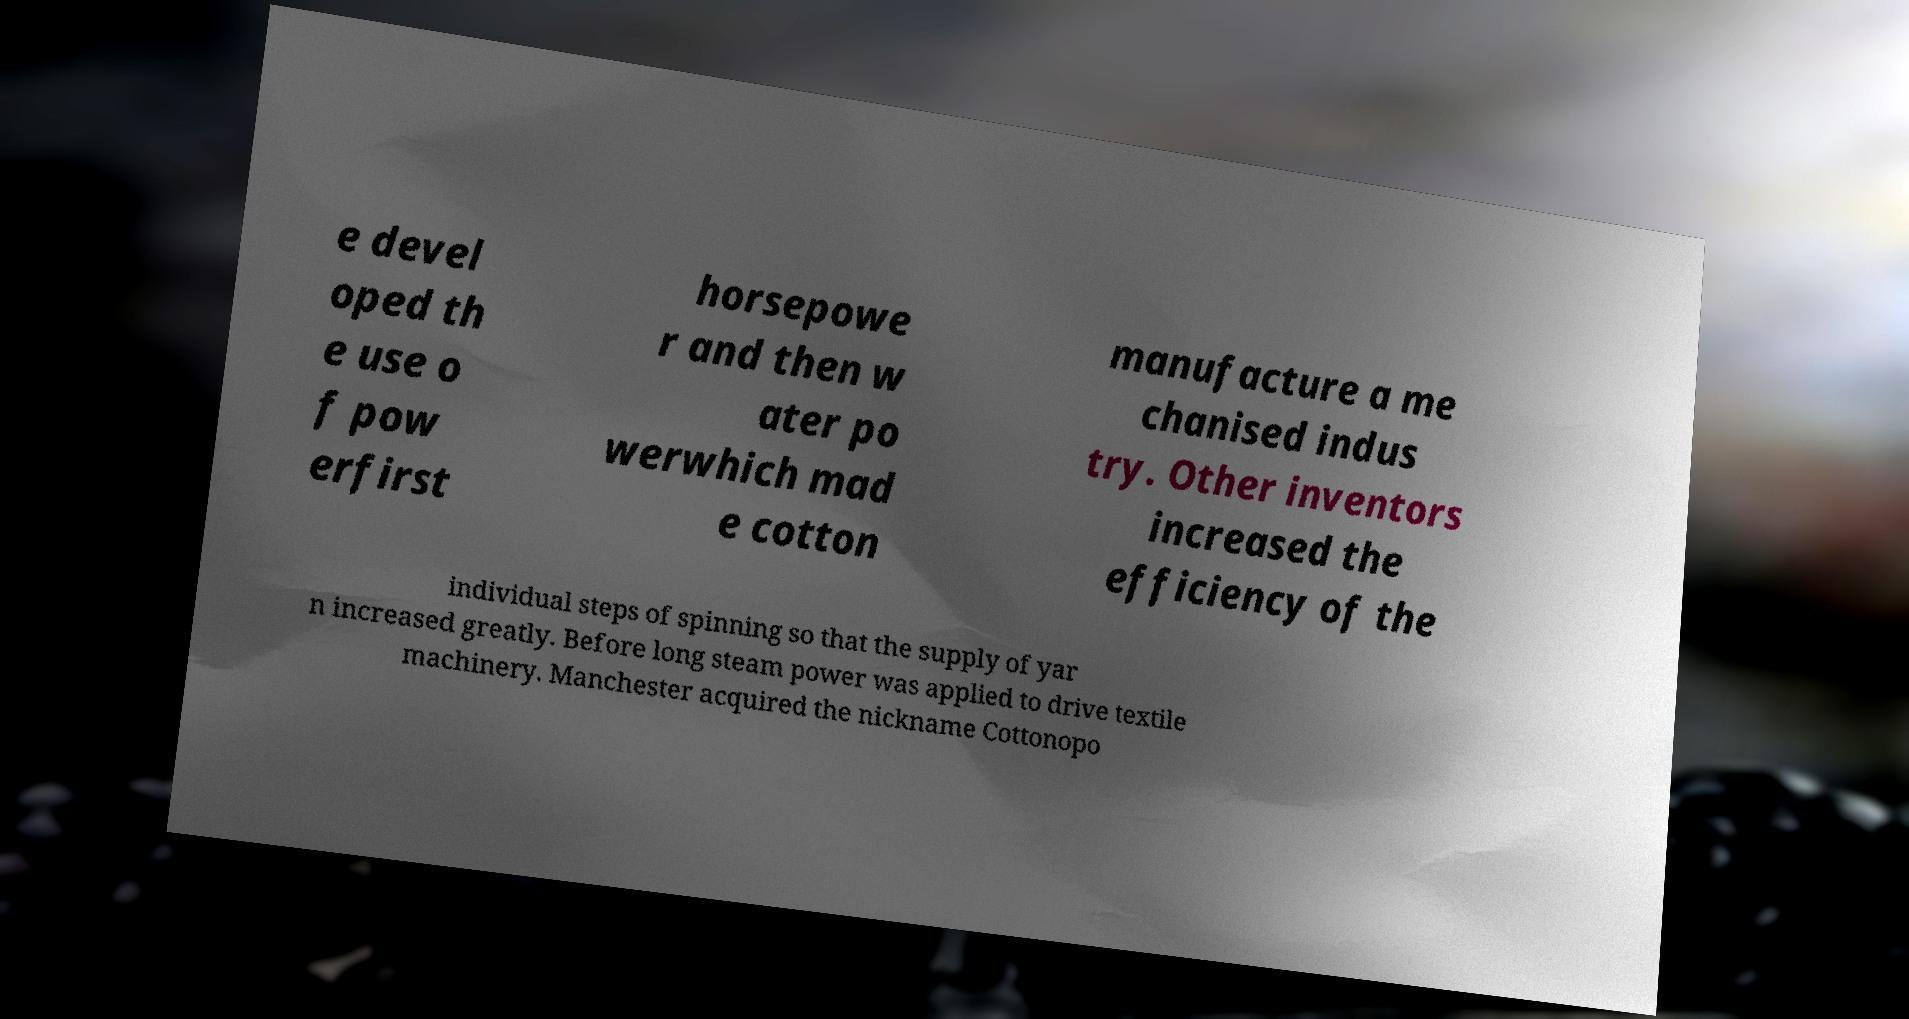Could you extract and type out the text from this image? e devel oped th e use o f pow erfirst horsepowe r and then w ater po werwhich mad e cotton manufacture a me chanised indus try. Other inventors increased the efficiency of the individual steps of spinning so that the supply of yar n increased greatly. Before long steam power was applied to drive textile machinery. Manchester acquired the nickname Cottonopo 